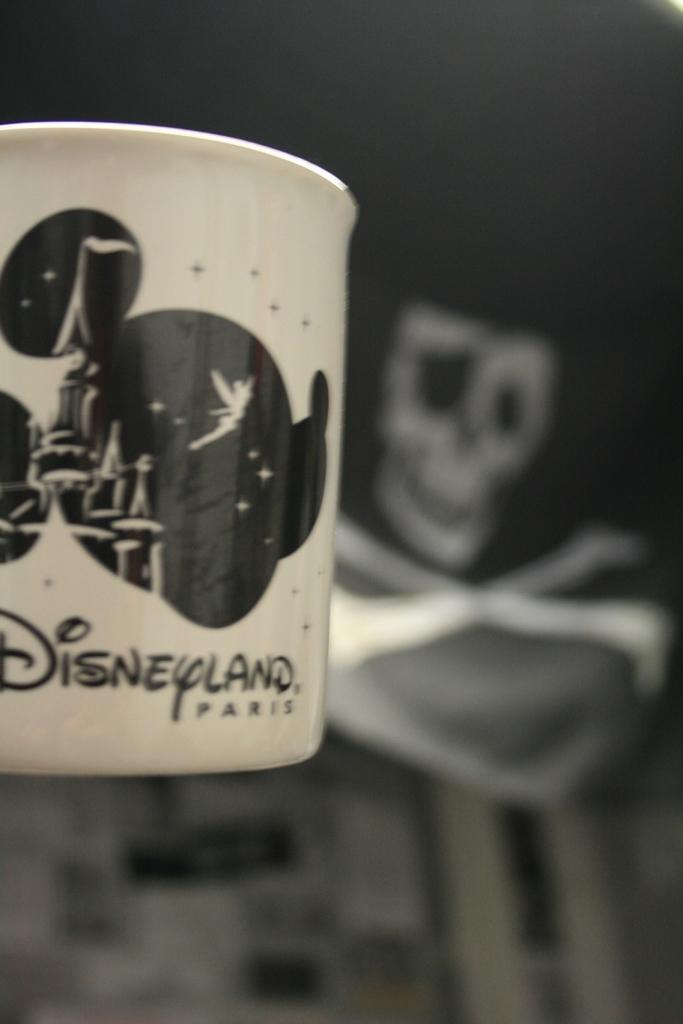What object can be seen in the image? There is a cup in the image. What can be observed about the background of the image? The background of the image is dark. How many friends are pushing the cup in the image? There are no friends or pushing actions present in the image; it only features a cup and a dark background. 